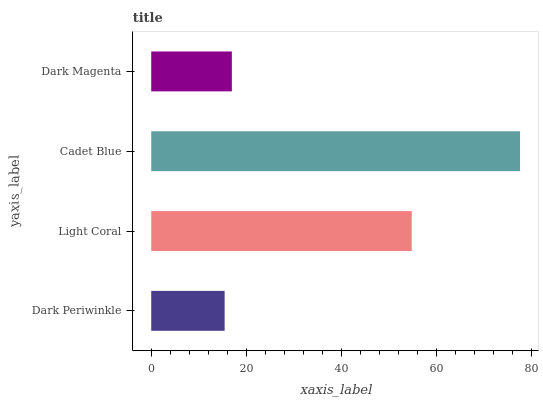Is Dark Periwinkle the minimum?
Answer yes or no. Yes. Is Cadet Blue the maximum?
Answer yes or no. Yes. Is Light Coral the minimum?
Answer yes or no. No. Is Light Coral the maximum?
Answer yes or no. No. Is Light Coral greater than Dark Periwinkle?
Answer yes or no. Yes. Is Dark Periwinkle less than Light Coral?
Answer yes or no. Yes. Is Dark Periwinkle greater than Light Coral?
Answer yes or no. No. Is Light Coral less than Dark Periwinkle?
Answer yes or no. No. Is Light Coral the high median?
Answer yes or no. Yes. Is Dark Magenta the low median?
Answer yes or no. Yes. Is Dark Magenta the high median?
Answer yes or no. No. Is Cadet Blue the low median?
Answer yes or no. No. 